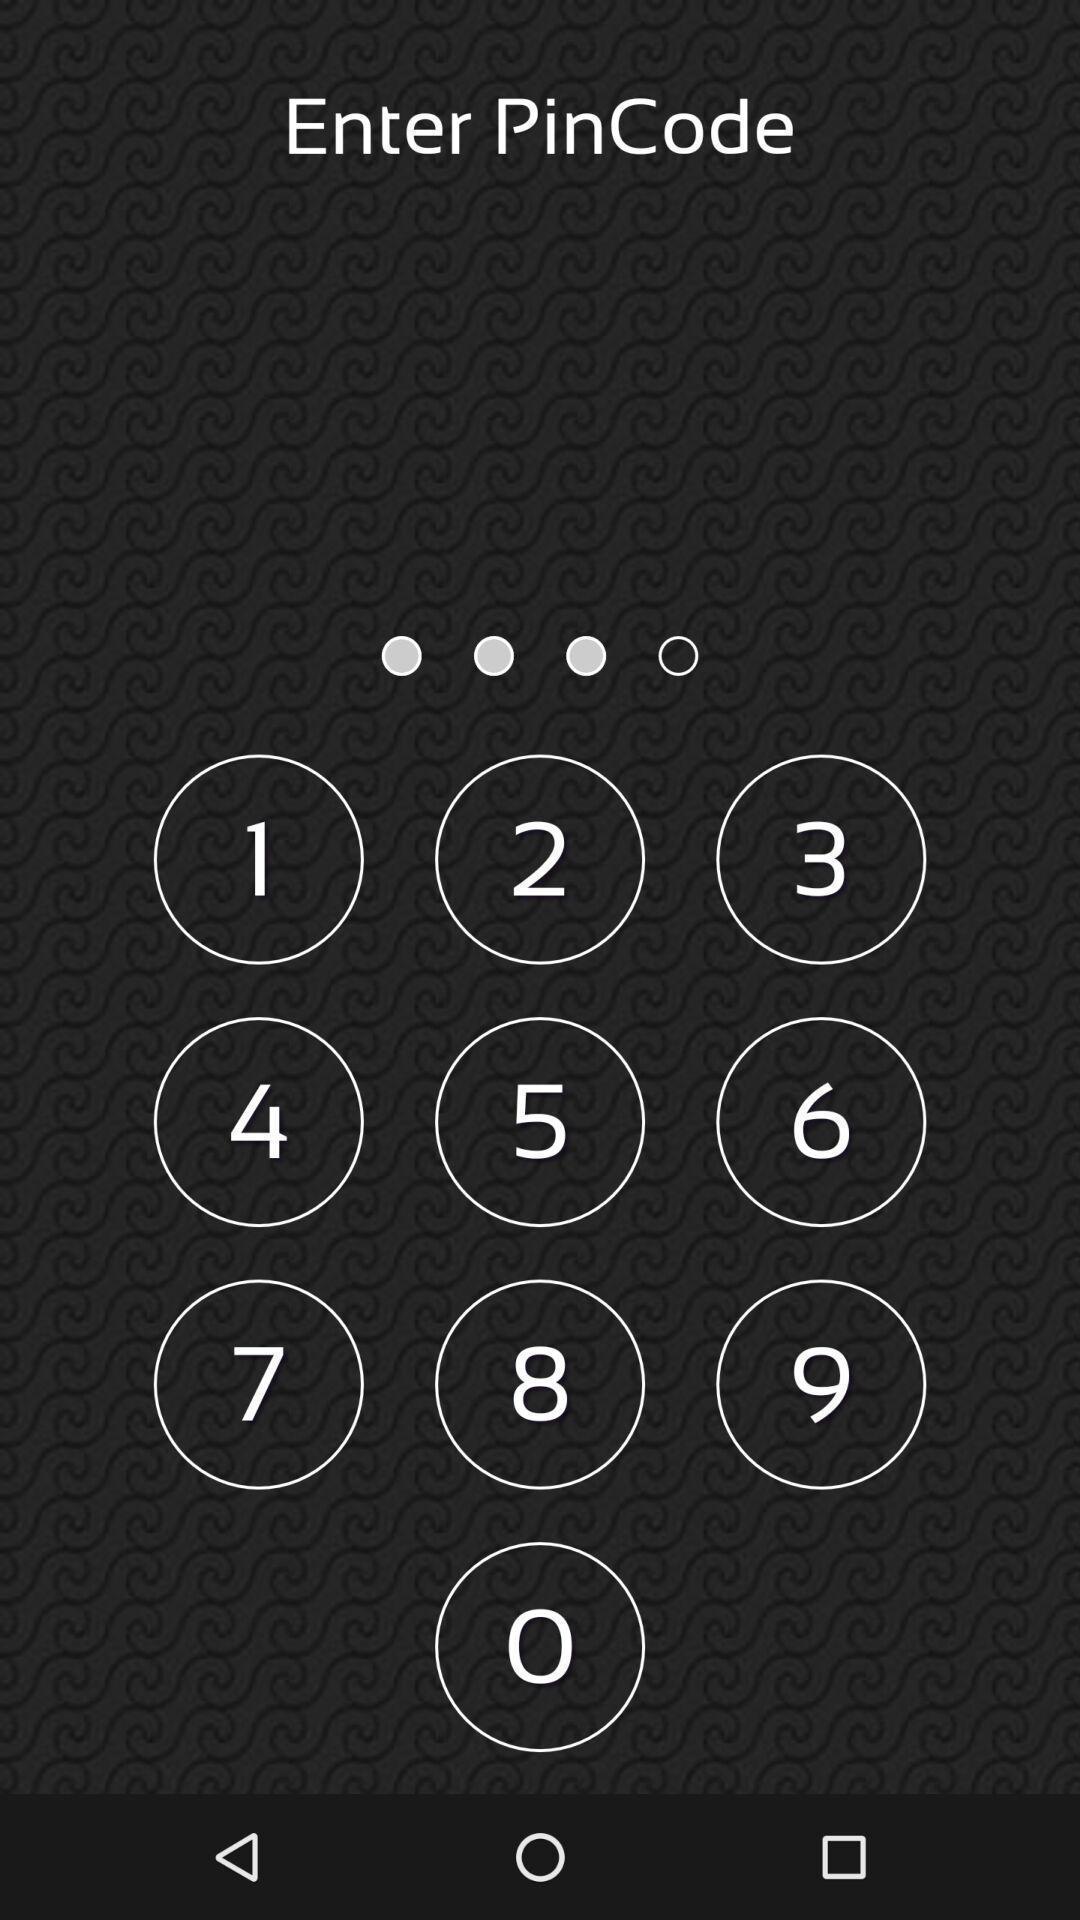Summarize the information in this screenshot. Page displaying to enter pincode. 